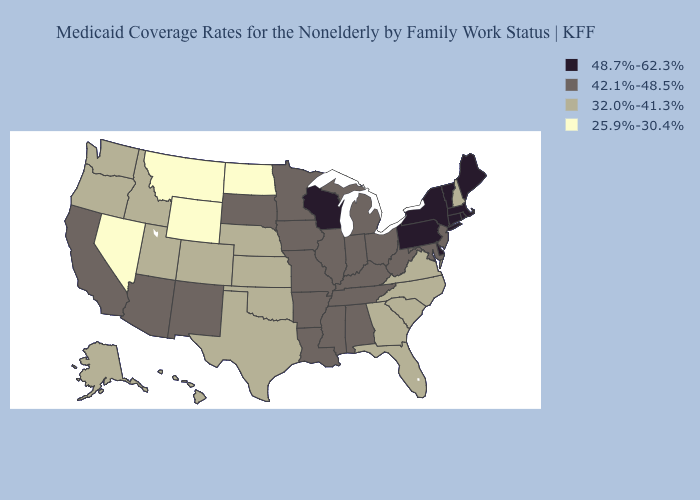Does Illinois have the lowest value in the MidWest?
Give a very brief answer. No. What is the value of Montana?
Give a very brief answer. 25.9%-30.4%. What is the highest value in the MidWest ?
Short answer required. 48.7%-62.3%. What is the lowest value in the West?
Answer briefly. 25.9%-30.4%. Which states have the lowest value in the USA?
Answer briefly. Montana, Nevada, North Dakota, Wyoming. Among the states that border New Jersey , which have the highest value?
Give a very brief answer. Delaware, New York, Pennsylvania. Does New Hampshire have the lowest value in the Northeast?
Short answer required. Yes. What is the value of West Virginia?
Short answer required. 42.1%-48.5%. Is the legend a continuous bar?
Short answer required. No. What is the value of Hawaii?
Write a very short answer. 32.0%-41.3%. Does New York have the highest value in the Northeast?
Be succinct. Yes. Name the states that have a value in the range 48.7%-62.3%?
Concise answer only. Connecticut, Delaware, Maine, Massachusetts, New York, Pennsylvania, Rhode Island, Vermont, Wisconsin. Which states have the lowest value in the USA?
Write a very short answer. Montana, Nevada, North Dakota, Wyoming. Does Maine have a higher value than New Jersey?
Be succinct. Yes. What is the highest value in the Northeast ?
Give a very brief answer. 48.7%-62.3%. 